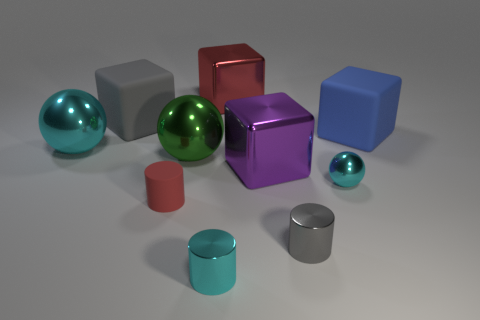There is a ball that is in front of the large green shiny thing; how many tiny rubber cylinders are left of it?
Offer a very short reply. 1. What number of other objects are the same shape as the large green metal object?
Give a very brief answer. 2. What number of objects are either large cyan metallic spheres or small objects to the right of the small cyan metallic cylinder?
Give a very brief answer. 3. Are there more rubber cylinders that are behind the purple object than shiny blocks that are behind the large gray rubber thing?
Ensure brevity in your answer.  No. There is a small cyan shiny thing that is behind the red object in front of the large rubber cube to the left of the large blue matte cube; what shape is it?
Your answer should be very brief. Sphere. What shape is the red thing that is right of the cyan metal cylinder that is on the right side of the large green shiny object?
Your answer should be compact. Cube. Is there a large red object made of the same material as the small ball?
Your answer should be compact. Yes. What is the size of the cylinder that is the same color as the tiny ball?
Your answer should be very brief. Small. What number of red things are cylinders or matte objects?
Your answer should be very brief. 1. Is there another rubber object of the same color as the small matte object?
Offer a very short reply. No. 